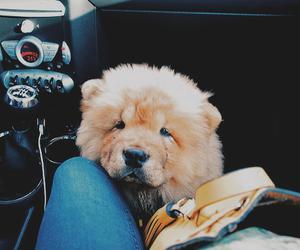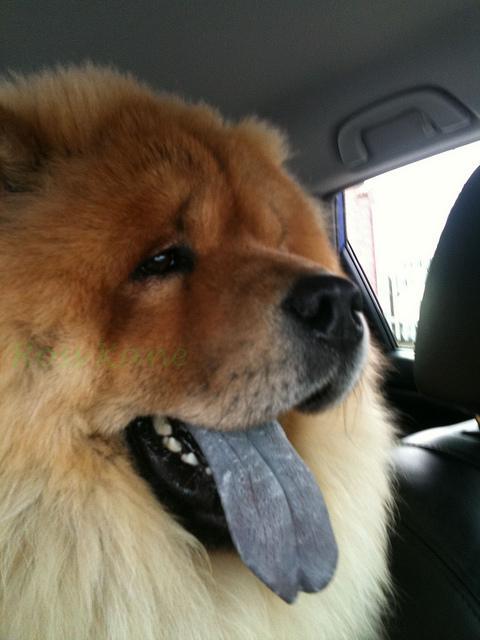The first image is the image on the left, the second image is the image on the right. For the images displayed, is the sentence "In one image of a chow dog, a human leg in jeans is visible." factually correct? Answer yes or no. Yes. The first image is the image on the left, the second image is the image on the right. Examine the images to the left and right. Is the description "Two dogs are sitting together in one of the images." accurate? Answer yes or no. No. 